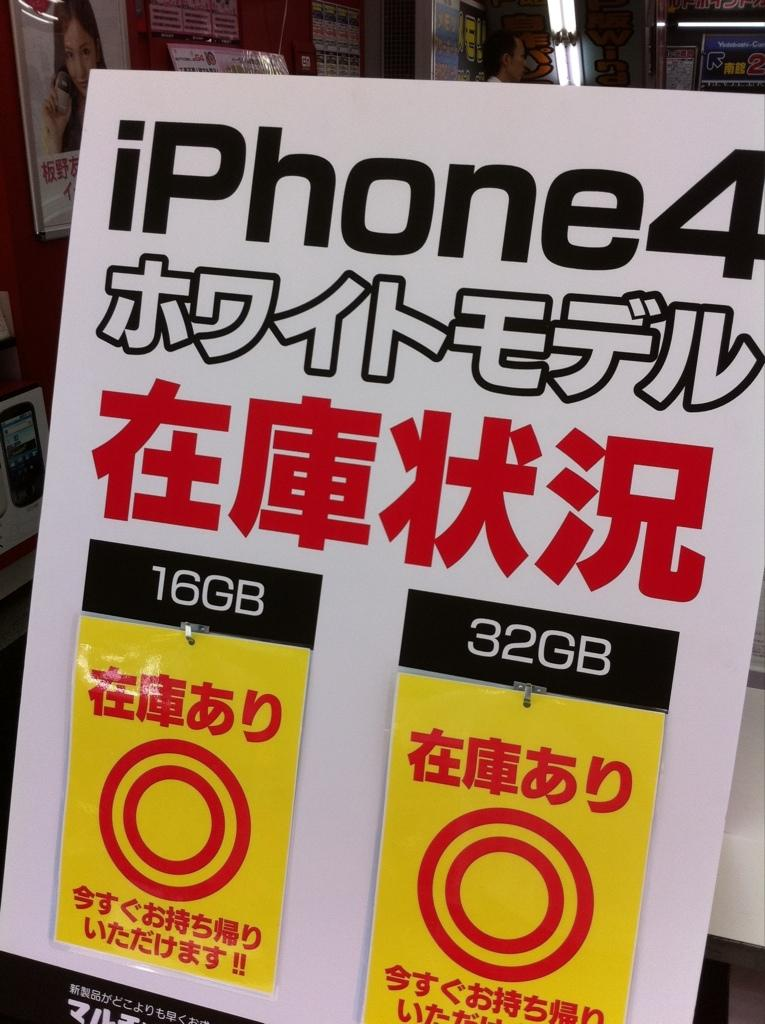<image>
Give a short and clear explanation of the subsequent image. One can purchase either the 16GB or 32GB versions of the iPhone 4 at the store. 